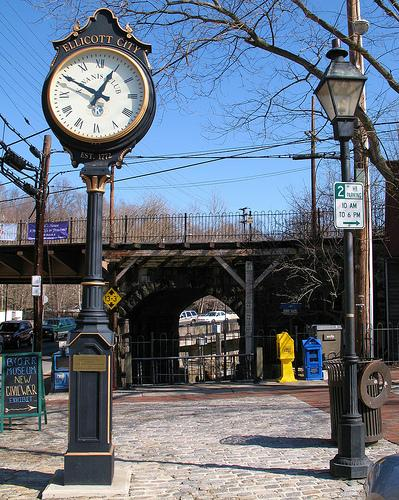Analyze the sentiment of the image based on the objects and their visual features. The sentiment of the image conveys a sense of calm, nostalgia, and history with its mix of lamp posts, signs, walkways, and the tall Ellicott City clock. Describe the overall scene in this image in one sentence. A picturesque scene of a bridge with parked cars, a tall clock, various signs, lamp posts, and walkways, all against a background of trees and a blue sky. What objects are interacting with the clock on a tall stand? The clock is attached to a pole, it has the words "Kiwanis Club" on its face, and it is also supported by a decorative lamp post. How is the quality of this image in terms of objects' details and visibility? The quality of the image is good, as objects' details like positions, sizes, and colors are clearly visible. How many signs are there in the image and what are the colors of the signs? There are 4 signs: a square green and white sign, a yellow sign with black numbers, a blue and white banner, and a white sign with green writing. Based on the objects in the image, what can you conclude about the location of this scene? The location appears to be in Ellicott City, as the Ellicott City clock is visible, along with other signs and objects that indicate a historic urban setting. Describe the ground surface in this image. The ground surface is a mix of brick-paved walkways and stone. Please count the number of lamp posts visible in the image. There are 5 lamp posts visible in the image. Can you find the purple bicycle leaning against a tree? The bicycle has a basket in the front. No, it's not mentioned in the image. 